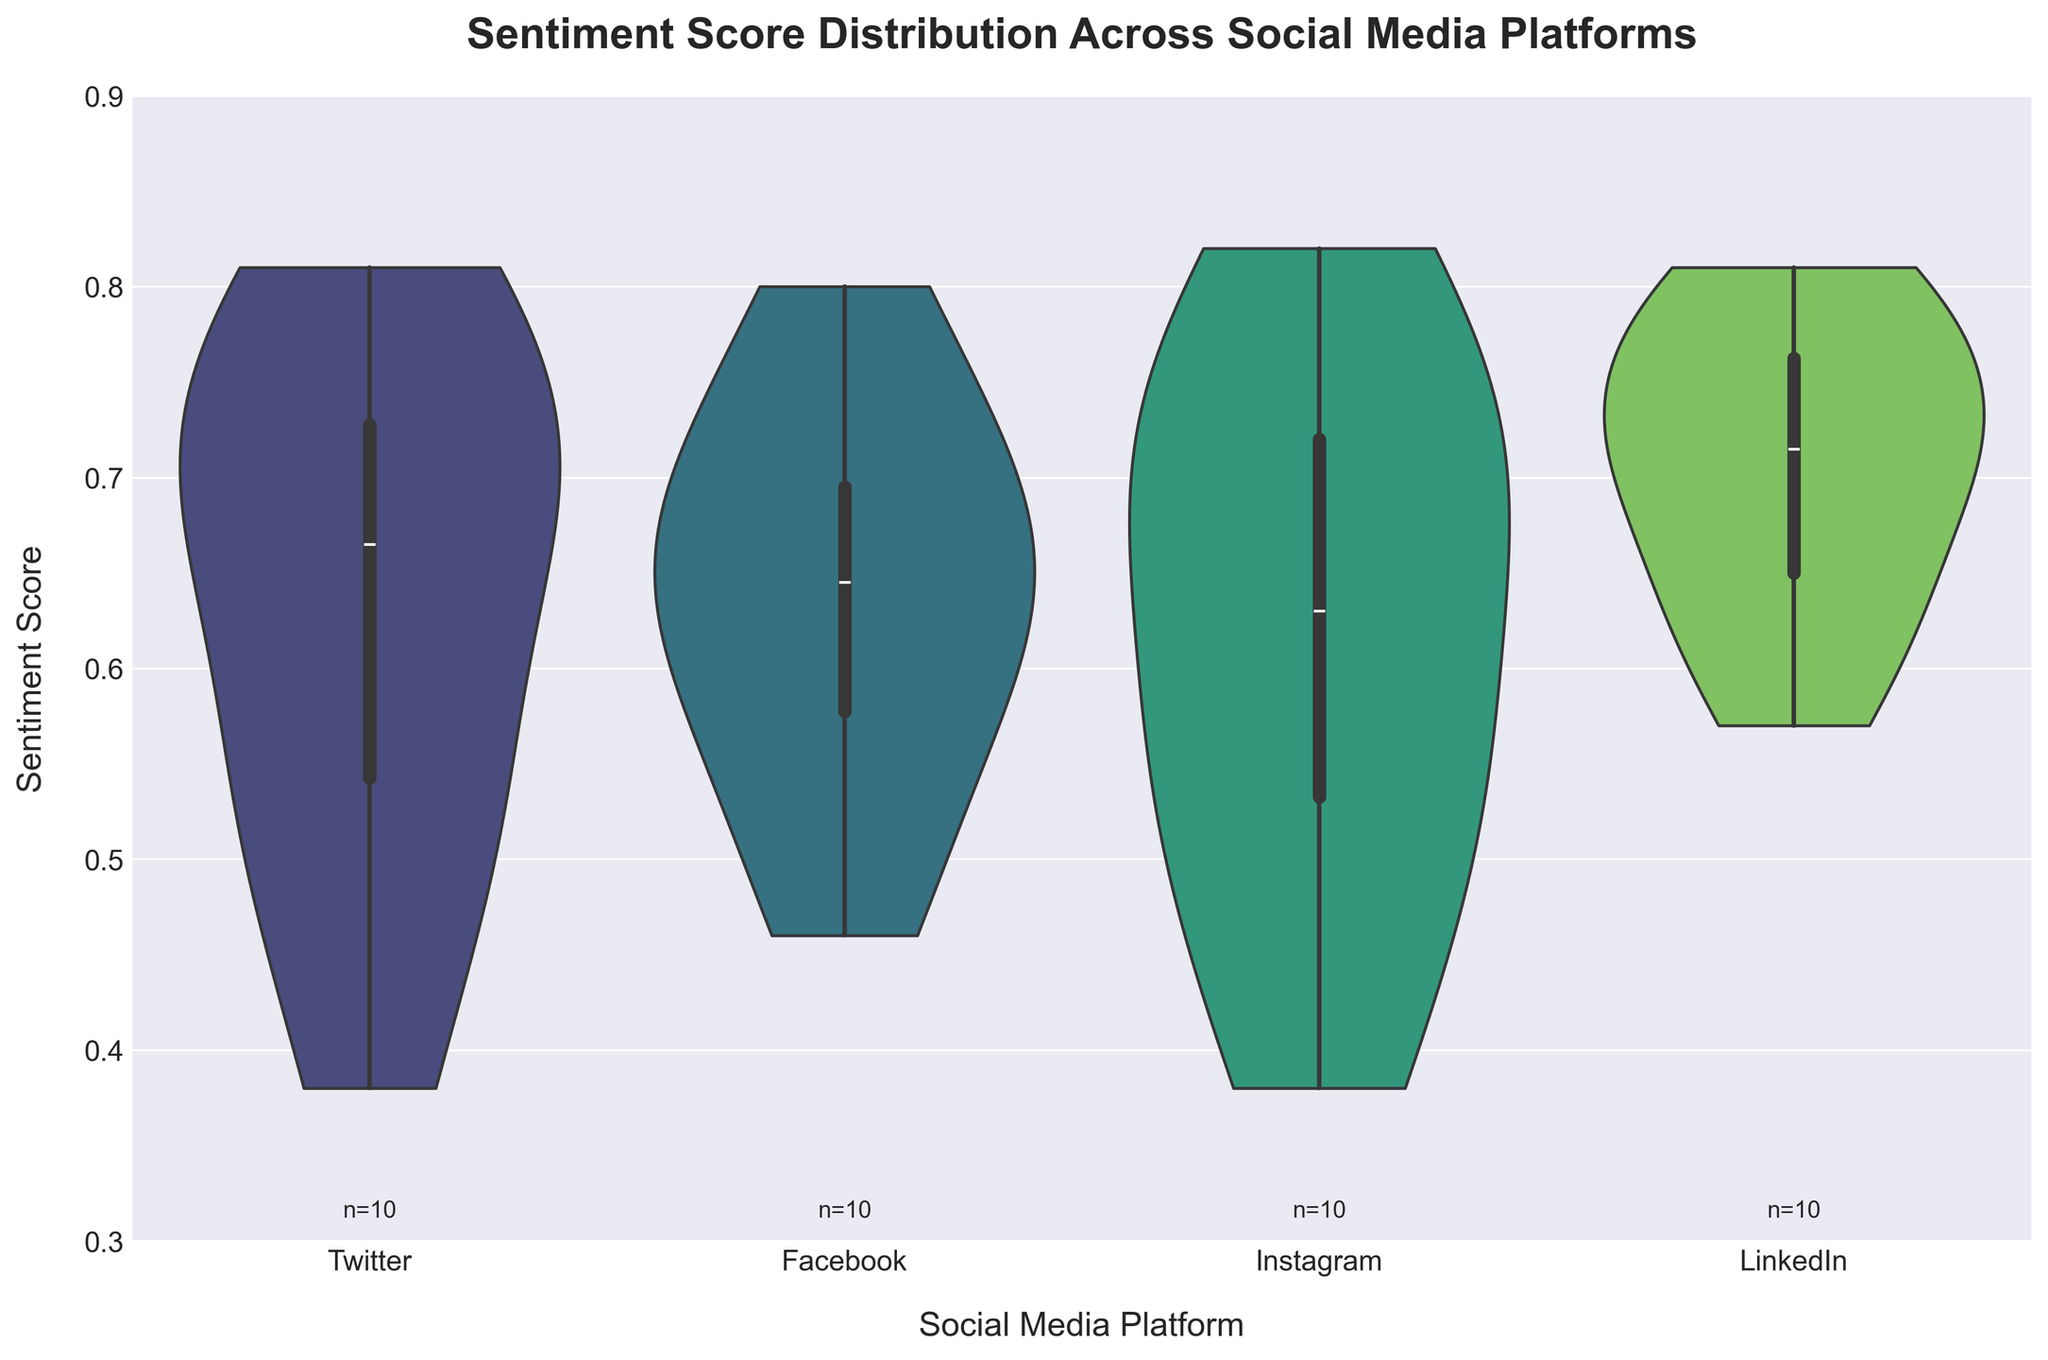What is the title of the chart? The title is typically found at the top of the chart. It usually describes what the chart represents. In this case, the chart's title is "Sentiment Score Distribution Across Social Media Platforms".
Answer: Sentiment Score Distribution Across Social Media Platforms Which platform has the highest median sentiment score? To determine the median sentiment score, look at the center of the white dot (representing the median) in each platform's violin plot. The highest median is slightly above the mark for "LinkedIn".
Answer: LinkedIn How many sentiment scores are represented for the "Twitter" platform? There is a text annotation at the bottom of each violin plot indicating the number of data points. For Twitter, the number displayed is "n=10".
Answer: 10 What is the range of the sentiment scores on the y-axis? The range is given by the y-axis limits. From the plot, it starts at 0.3 and ends at 0.9.
Answer: 0.3 to 0.9 Which platform has the widest spread of sentiment scores? The spread of sentiment scores can be inferred from the width of the violin plot. The platform with the widest part of the plot (indicating the spread) could be "Instagram".
Answer: Instagram Between Facebook and Twitter, which platform has a higher maximum sentiment score? To find which has the higher maximum score, locate the upper bound of the violin for both Facebook and Twitter. Facebook's top edge is slightly higher than Twitter's.
Answer: Facebook On which platform is the lowest sentiment score observed? Identify the lowest point on each violin plot to find the lowest sentiment. The lowest sentiment score occurs at the bottom of the violin plot for "Instagram".
Answer: Instagram What is the median sentiment score for the "Instagram" platform? The median sentiment score is indicated by the central white dot within the violin plot. For Instagram, this dot is around 0.60.
Answer: 0.60 Are there any platforms with sentiment scores not exceeding 0.8? By looking at the upper end of each violin plot, platforms like Twitter and Instagram do not have sentiment scores exceeding 0.8, as their violins do not extend past this value.
Answer: Twitter, Instagram 